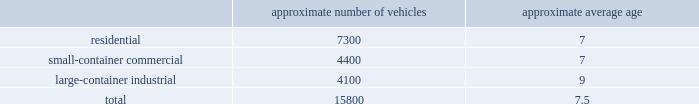Acquire operations and facilities from municipalities and other local governments , as they increasingly seek to raise capital and reduce risk .
We realize synergies from consolidating businesses into our existing operations , whether through acquisitions or public-private partnerships , which allow us to reduce capital and expense requirements associated with truck routing , personnel , fleet maintenance , inventories and back-office administration .
Operating model the goal of our operating model pillar is to deliver a consistent , high quality service to all of our customers through the republic way : one way .
Everywhere .
Every day .
This approach of developing standardized processes with rigorous controls and tracking allows us to leverage our scale and deliver durable operational excellence .
The republic way is the key to harnessing the best of what we do as operators and translating that across all facets of our business .
A key enabler of the republic way is our organizational structure that fosters a high performance culture by maintaining 360 degree accountability and full profit and loss responsibility with local management , supported by a functional structure to provide subject matter expertise .
This structure allows us to take advantage of our scale by coordinating functionally across all of our markets , while empowering local management to respond to unique market dynamics .
We have rolled out several productivity and cost control initiatives designed to deliver the best service possible to our customers in the most efficient and environmentally sound way .
Fleet automation approximately 74% ( 74 % ) of our residential routes have been converted to automated single driver trucks .
By converting our residential routes to automated service , we reduce labor costs , improve driver productivity , decrease emissions and create a safer work environment for our employees .
Additionally , communities using automated vehicles have higher participation rates in recycling programs , thereby complementing our initiative to expand our recycling capabilities .
Fleet conversion to compressed natural gas ( cng ) approximately 18% ( 18 % ) of our fleet operates on natural gas .
We expect to continue our gradual fleet conversion to cng , our preferred alternative fuel technology , as part of our ordinary annual fleet replacement process .
We believe a gradual fleet conversion is most prudent to realize the full value of our previous fleet investments .
Approximately 36% ( 36 % ) of our replacement vehicle purchases during 2016 were cng vehicles .
We believe using cng vehicles provides us a competitive advantage in communities with strict clean emission initiatives that focus on protecting the environment .
Although upfront capital costs are higher , using cng reduces our overall fleet operating costs through lower fuel expenses .
As of december 31 , 2016 , we operated 38 cng fueling stations .
Standardized maintenance based on an industry trade publication , we operate the eighth largest vocational fleet in the united states .
As of december 31 , 2016 , our average fleet age in years , by line of business , was as follows : approximate number of vehicles approximate average age .

What is the approximate number of vehicles that have been converted to compressed natural gas ( cng )? 
Rationale: 2844 vehicles in the fleet have been converted to compressed natural gas
Computations: (15800 * 18%)
Answer: 2844.0. 